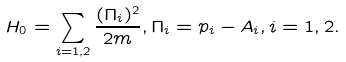<formula> <loc_0><loc_0><loc_500><loc_500>H _ { 0 } = \sum _ { i = 1 , 2 } \frac { ( \Pi _ { i } ) ^ { 2 } } { 2 m } , \Pi _ { i } = p _ { i } - A _ { i } , i = 1 , 2 .</formula> 